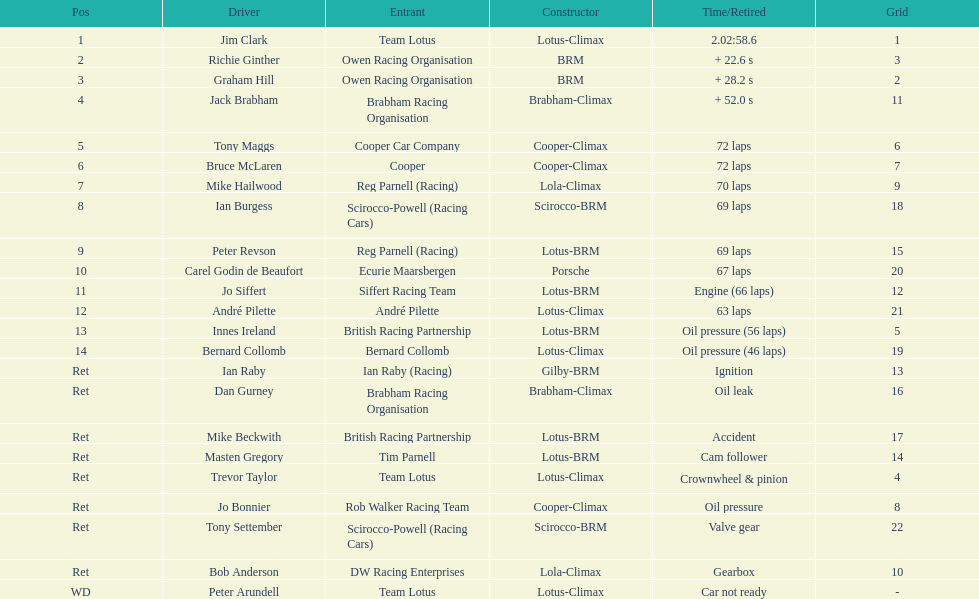How many unique drivers are specified? 23. 